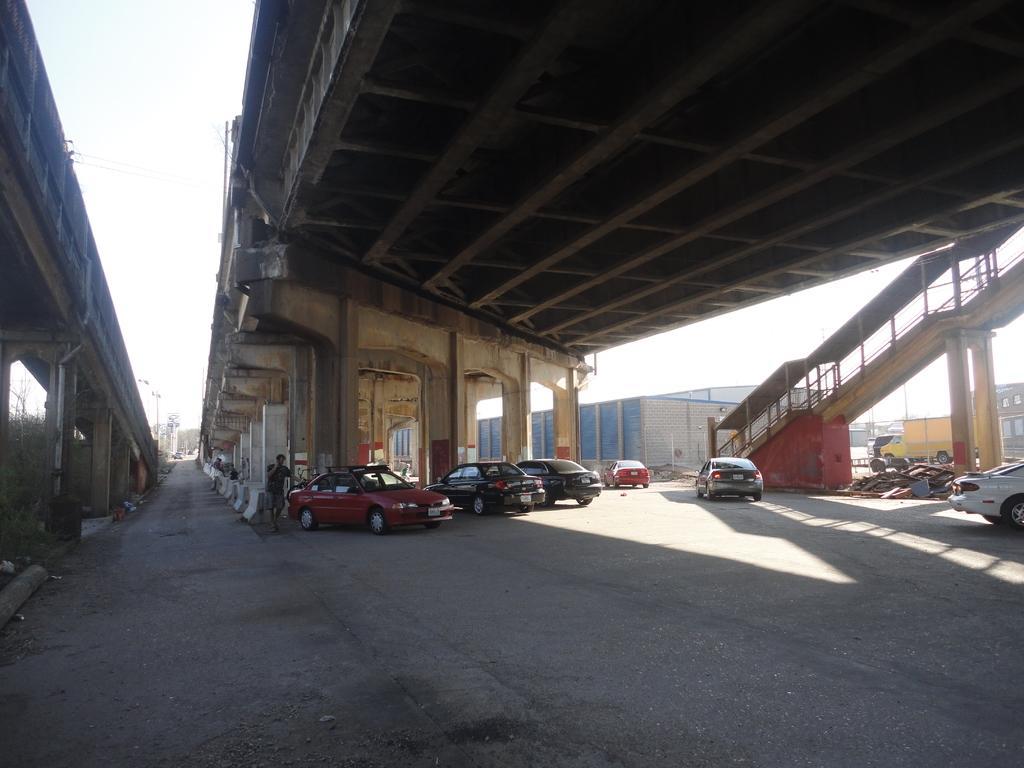In one or two sentences, can you explain what this image depicts? In this image I can see the ground, few vehicles on the ground, a person standing, few pillars, two bridges and few buildings. In the background I can see the sky. 